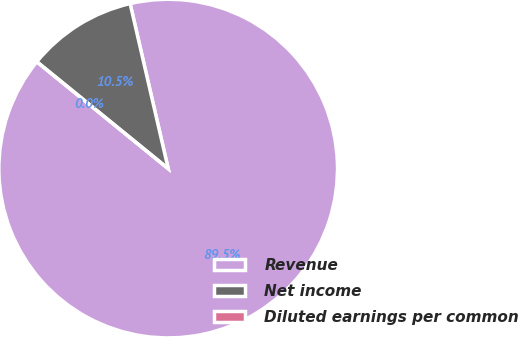Convert chart. <chart><loc_0><loc_0><loc_500><loc_500><pie_chart><fcel>Revenue<fcel>Net income<fcel>Diluted earnings per common<nl><fcel>89.48%<fcel>10.52%<fcel>0.0%<nl></chart> 